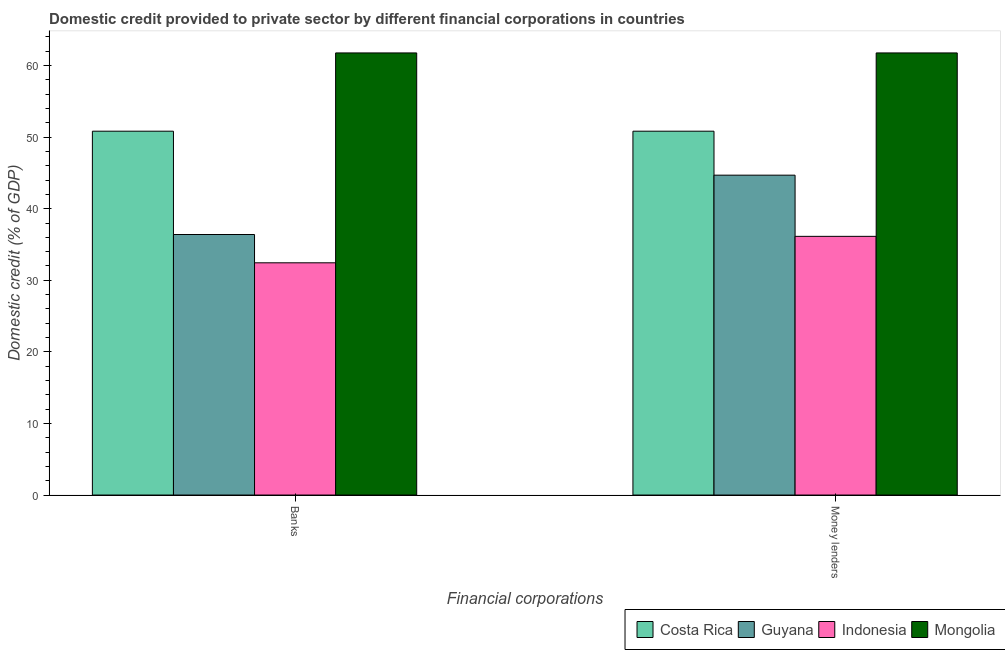How many different coloured bars are there?
Make the answer very short. 4. How many groups of bars are there?
Your answer should be compact. 2. How many bars are there on the 1st tick from the right?
Ensure brevity in your answer.  4. What is the label of the 1st group of bars from the left?
Your response must be concise. Banks. What is the domestic credit provided by money lenders in Costa Rica?
Keep it short and to the point. 50.83. Across all countries, what is the maximum domestic credit provided by banks?
Ensure brevity in your answer.  61.76. Across all countries, what is the minimum domestic credit provided by banks?
Keep it short and to the point. 32.44. In which country was the domestic credit provided by banks maximum?
Your answer should be very brief. Mongolia. In which country was the domestic credit provided by money lenders minimum?
Your answer should be compact. Indonesia. What is the total domestic credit provided by money lenders in the graph?
Ensure brevity in your answer.  193.42. What is the difference between the domestic credit provided by money lenders in Costa Rica and that in Guyana?
Offer a terse response. 6.14. What is the difference between the domestic credit provided by money lenders in Mongolia and the domestic credit provided by banks in Guyana?
Provide a succinct answer. 25.37. What is the average domestic credit provided by banks per country?
Provide a succinct answer. 45.36. What is the difference between the domestic credit provided by banks and domestic credit provided by money lenders in Mongolia?
Your answer should be compact. 0. What is the ratio of the domestic credit provided by money lenders in Costa Rica to that in Guyana?
Your response must be concise. 1.14. Is the domestic credit provided by banks in Guyana less than that in Indonesia?
Your answer should be very brief. No. In how many countries, is the domestic credit provided by money lenders greater than the average domestic credit provided by money lenders taken over all countries?
Provide a short and direct response. 2. What does the 2nd bar from the left in Banks represents?
Provide a short and direct response. Guyana. What does the 3rd bar from the right in Money lenders represents?
Your response must be concise. Guyana. How many bars are there?
Provide a succinct answer. 8. Are all the bars in the graph horizontal?
Offer a very short reply. No. What is the difference between two consecutive major ticks on the Y-axis?
Provide a succinct answer. 10. Does the graph contain any zero values?
Ensure brevity in your answer.  No. Where does the legend appear in the graph?
Ensure brevity in your answer.  Bottom right. How many legend labels are there?
Offer a very short reply. 4. What is the title of the graph?
Your response must be concise. Domestic credit provided to private sector by different financial corporations in countries. What is the label or title of the X-axis?
Offer a very short reply. Financial corporations. What is the label or title of the Y-axis?
Offer a very short reply. Domestic credit (% of GDP). What is the Domestic credit (% of GDP) in Costa Rica in Banks?
Your answer should be compact. 50.83. What is the Domestic credit (% of GDP) of Guyana in Banks?
Ensure brevity in your answer.  36.4. What is the Domestic credit (% of GDP) of Indonesia in Banks?
Ensure brevity in your answer.  32.44. What is the Domestic credit (% of GDP) of Mongolia in Banks?
Offer a very short reply. 61.76. What is the Domestic credit (% of GDP) of Costa Rica in Money lenders?
Make the answer very short. 50.83. What is the Domestic credit (% of GDP) of Guyana in Money lenders?
Offer a very short reply. 44.69. What is the Domestic credit (% of GDP) in Indonesia in Money lenders?
Offer a terse response. 36.14. What is the Domestic credit (% of GDP) in Mongolia in Money lenders?
Your answer should be compact. 61.76. Across all Financial corporations, what is the maximum Domestic credit (% of GDP) of Costa Rica?
Your answer should be compact. 50.83. Across all Financial corporations, what is the maximum Domestic credit (% of GDP) of Guyana?
Your response must be concise. 44.69. Across all Financial corporations, what is the maximum Domestic credit (% of GDP) of Indonesia?
Keep it short and to the point. 36.14. Across all Financial corporations, what is the maximum Domestic credit (% of GDP) of Mongolia?
Your answer should be compact. 61.76. Across all Financial corporations, what is the minimum Domestic credit (% of GDP) of Costa Rica?
Ensure brevity in your answer.  50.83. Across all Financial corporations, what is the minimum Domestic credit (% of GDP) in Guyana?
Provide a succinct answer. 36.4. Across all Financial corporations, what is the minimum Domestic credit (% of GDP) of Indonesia?
Your answer should be very brief. 32.44. Across all Financial corporations, what is the minimum Domestic credit (% of GDP) in Mongolia?
Provide a succinct answer. 61.76. What is the total Domestic credit (% of GDP) in Costa Rica in the graph?
Offer a very short reply. 101.66. What is the total Domestic credit (% of GDP) in Guyana in the graph?
Your response must be concise. 81.08. What is the total Domestic credit (% of GDP) in Indonesia in the graph?
Offer a very short reply. 68.58. What is the total Domestic credit (% of GDP) in Mongolia in the graph?
Make the answer very short. 123.53. What is the difference between the Domestic credit (% of GDP) of Guyana in Banks and that in Money lenders?
Ensure brevity in your answer.  -8.29. What is the difference between the Domestic credit (% of GDP) of Indonesia in Banks and that in Money lenders?
Keep it short and to the point. -3.7. What is the difference between the Domestic credit (% of GDP) in Mongolia in Banks and that in Money lenders?
Ensure brevity in your answer.  0. What is the difference between the Domestic credit (% of GDP) in Costa Rica in Banks and the Domestic credit (% of GDP) in Guyana in Money lenders?
Offer a very short reply. 6.14. What is the difference between the Domestic credit (% of GDP) in Costa Rica in Banks and the Domestic credit (% of GDP) in Indonesia in Money lenders?
Provide a succinct answer. 14.69. What is the difference between the Domestic credit (% of GDP) in Costa Rica in Banks and the Domestic credit (% of GDP) in Mongolia in Money lenders?
Make the answer very short. -10.93. What is the difference between the Domestic credit (% of GDP) in Guyana in Banks and the Domestic credit (% of GDP) in Indonesia in Money lenders?
Make the answer very short. 0.26. What is the difference between the Domestic credit (% of GDP) in Guyana in Banks and the Domestic credit (% of GDP) in Mongolia in Money lenders?
Offer a very short reply. -25.37. What is the difference between the Domestic credit (% of GDP) of Indonesia in Banks and the Domestic credit (% of GDP) of Mongolia in Money lenders?
Your answer should be compact. -29.32. What is the average Domestic credit (% of GDP) of Costa Rica per Financial corporations?
Your response must be concise. 50.83. What is the average Domestic credit (% of GDP) of Guyana per Financial corporations?
Provide a short and direct response. 40.54. What is the average Domestic credit (% of GDP) in Indonesia per Financial corporations?
Your answer should be very brief. 34.29. What is the average Domestic credit (% of GDP) in Mongolia per Financial corporations?
Provide a short and direct response. 61.76. What is the difference between the Domestic credit (% of GDP) in Costa Rica and Domestic credit (% of GDP) in Guyana in Banks?
Provide a succinct answer. 14.43. What is the difference between the Domestic credit (% of GDP) of Costa Rica and Domestic credit (% of GDP) of Indonesia in Banks?
Your answer should be compact. 18.39. What is the difference between the Domestic credit (% of GDP) in Costa Rica and Domestic credit (% of GDP) in Mongolia in Banks?
Provide a succinct answer. -10.93. What is the difference between the Domestic credit (% of GDP) of Guyana and Domestic credit (% of GDP) of Indonesia in Banks?
Your response must be concise. 3.95. What is the difference between the Domestic credit (% of GDP) of Guyana and Domestic credit (% of GDP) of Mongolia in Banks?
Your response must be concise. -25.37. What is the difference between the Domestic credit (% of GDP) in Indonesia and Domestic credit (% of GDP) in Mongolia in Banks?
Make the answer very short. -29.32. What is the difference between the Domestic credit (% of GDP) in Costa Rica and Domestic credit (% of GDP) in Guyana in Money lenders?
Give a very brief answer. 6.14. What is the difference between the Domestic credit (% of GDP) in Costa Rica and Domestic credit (% of GDP) in Indonesia in Money lenders?
Offer a terse response. 14.69. What is the difference between the Domestic credit (% of GDP) of Costa Rica and Domestic credit (% of GDP) of Mongolia in Money lenders?
Offer a very short reply. -10.93. What is the difference between the Domestic credit (% of GDP) of Guyana and Domestic credit (% of GDP) of Indonesia in Money lenders?
Keep it short and to the point. 8.55. What is the difference between the Domestic credit (% of GDP) of Guyana and Domestic credit (% of GDP) of Mongolia in Money lenders?
Make the answer very short. -17.08. What is the difference between the Domestic credit (% of GDP) in Indonesia and Domestic credit (% of GDP) in Mongolia in Money lenders?
Provide a succinct answer. -25.62. What is the ratio of the Domestic credit (% of GDP) in Costa Rica in Banks to that in Money lenders?
Offer a terse response. 1. What is the ratio of the Domestic credit (% of GDP) of Guyana in Banks to that in Money lenders?
Provide a short and direct response. 0.81. What is the ratio of the Domestic credit (% of GDP) in Indonesia in Banks to that in Money lenders?
Your answer should be compact. 0.9. What is the difference between the highest and the second highest Domestic credit (% of GDP) of Guyana?
Provide a short and direct response. 8.29. What is the difference between the highest and the second highest Domestic credit (% of GDP) of Indonesia?
Provide a succinct answer. 3.7. What is the difference between the highest and the lowest Domestic credit (% of GDP) in Costa Rica?
Provide a short and direct response. 0. What is the difference between the highest and the lowest Domestic credit (% of GDP) in Guyana?
Provide a short and direct response. 8.29. What is the difference between the highest and the lowest Domestic credit (% of GDP) of Indonesia?
Your answer should be very brief. 3.7. What is the difference between the highest and the lowest Domestic credit (% of GDP) in Mongolia?
Your response must be concise. 0. 